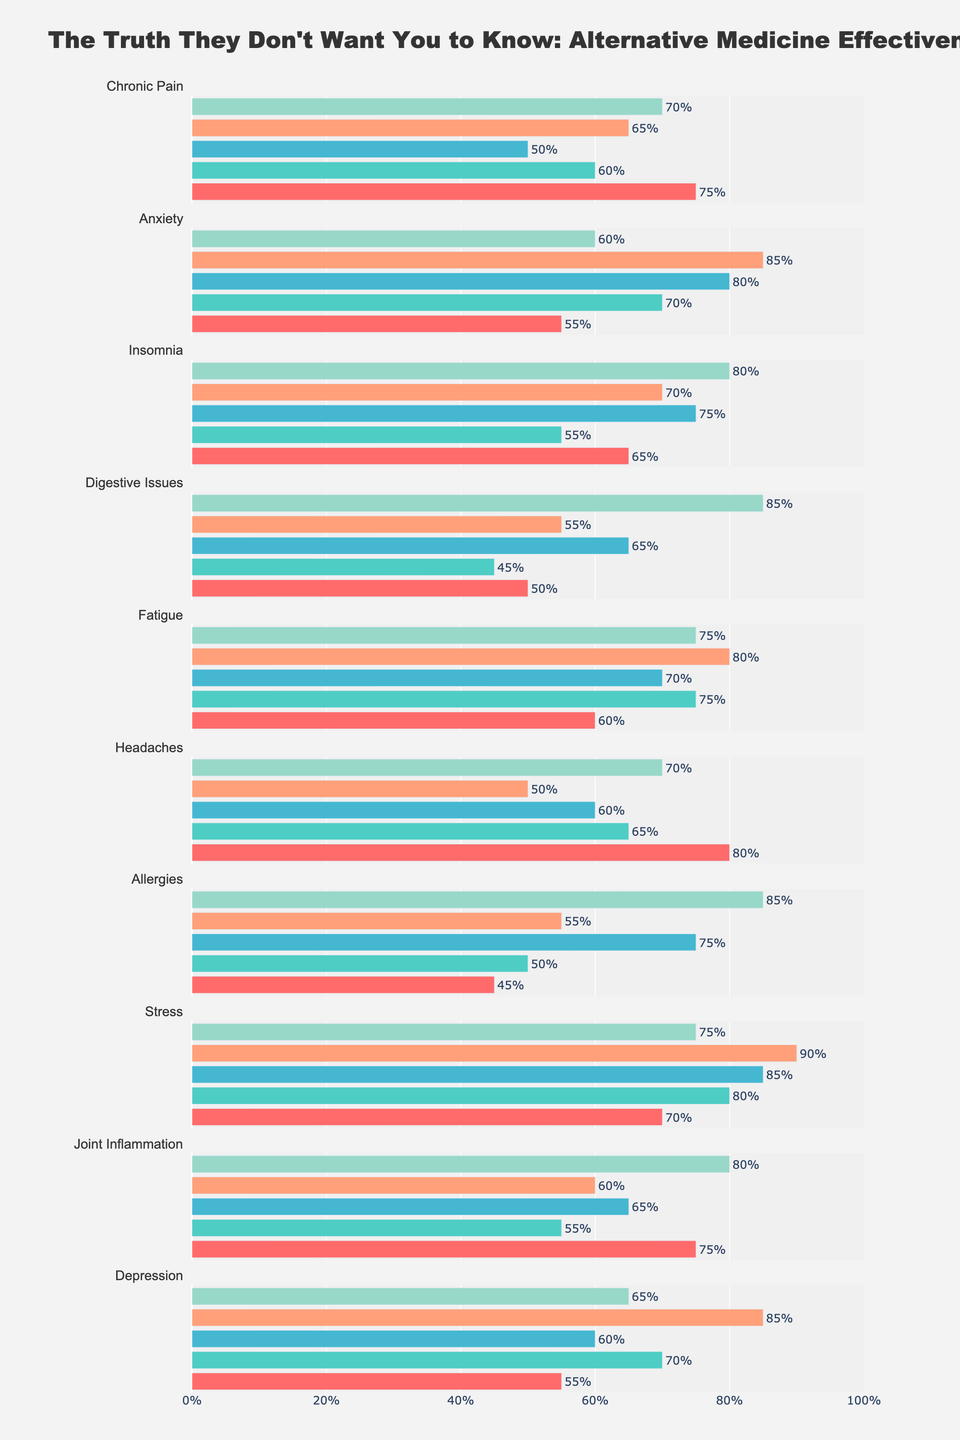Which alternative treatment is perceived as the most effective for treating stress? The figure shows a horizontal bar chart for stress, with different treatments and their perceived effectiveness. The bar for Reiki is the longest, indicating it is the most effective for stress with 90%.
Answer: Reiki How effective is crystal healing for treating anxiety compared to treating fatigue? Look at the horizontal bars for anxiety and fatigue under the crystal healing treatment. For anxiety, the bar is at 70%, and for fatigue, it is at 75%. The effectiveness is 5% higher for fatigue.
Answer: 5% more effective for fatigue Which ailment has the lowest perceived effectiveness for herbal remedies? Scan the bars representing herbal remedies for each ailment. The shortest bar is at 60% for anxiety and digestive issues.
Answer: Anxiety and Digestive Issues What is the average perceived effectiveness of acupuncture across all ailments? Sum the effectiveness percentages for acupuncture for each ailment and divide by the number of ailments: (75+55+65+50+60+80+45+70+75+55)/10 = 63%.
Answer: 63% Which ailment shows the greatest difference between the highest and lowest perceived effectiveness treatments? For each ailment, calculate the difference between the highest and lowest perceived effectiveness percentages: 
- Chronic Pain: 75% - 50% = 25%
- Anxiety: 85% - 55% = 30%
- Insomnia: 80% - 55% = 25%
- Digestive Issues: 85% - 45% = 40%
- Fatigue: 80% - 60% = 20%
- Headaches: 80% - 50% = 30%
- Allergies: 85% - 45% = 40%
- Stress: 90% - 70% = 20%
- Joint Inflammation: 80% - 55% = 25%
- Depression: 85% - 55% = 30%
Digestive issues and allergies both show the greatest difference of 40%.
Answer: Digestive Issues and Allergies For which ailment is essential oils perceived more effective than crystal healing and by how much? Compare the bars for essential oils and crystal healing for each ailment and identify where essential oils has a greater percentage:
- Anxiety: 80% - 70% = 10%
- Insomnia: 75% - 55% = 20%
- Digestive Issues: 65% - 45% = 20%
- Allergies: 75% - 50% = 25%
- Stress: 85% - 80% = 5%
- Joint Inflammation: 65% - 55% = 10%
Essential oils are perceived as more effective for anxiety, insomnia, digestive issues, allergies, stress, and joint inflammation. The highest difference is 25% for allergies.
Answer: Allergies, 25% Which alternative treatment is perceived as the least effective for chronic pain? Check the shortest bar for chronic pain. The shortest bar represents essential oils at 50%.
Answer: Essential Oils What is the combined perceived effectiveness of Reiki for both depression and fatigue? Add the percentages for Reiki in depression and fatigue: 85% + 80% = 165%.
Answer: 165% Which treatment has a higher perceived effectiveness for headaches: acupuncture or herbal remedies, and by how much? Compare the bars for acupuncture and herbal remedies under headaches. Acupuncture is at 80%, and herbal remedies are at 70%, making acupuncture higher by 10%.
Answer: Acupuncture, 10% 